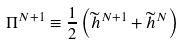<formula> <loc_0><loc_0><loc_500><loc_500>\Pi ^ { N + 1 } \equiv \frac { 1 } { 2 } \left ( \widetilde { h } ^ { N + 1 } + \widetilde { h } ^ { N } \right )</formula> 